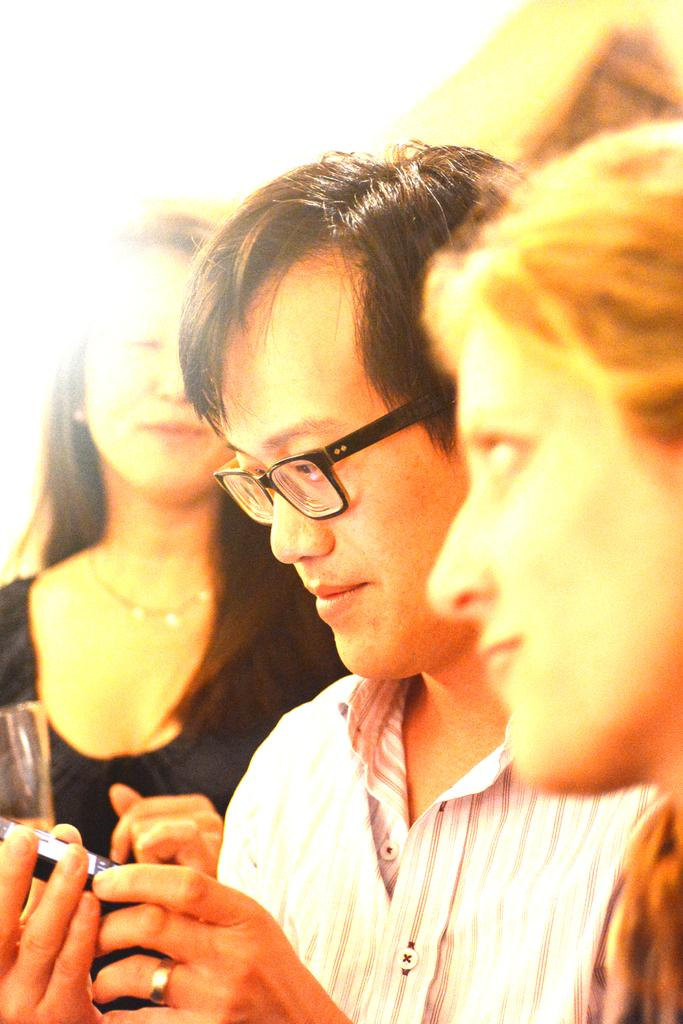Who are the people in the foreground of the image? There is a woman and a man in the foreground of the image. What is the man holding in the image? The man is holding a mobile in the image. Who is behind the man in the image? There is another woman behind the man in the image. What might the woman behind the man be holding? The woman behind the man appears to be holding a glass in the image. What is the price of the quarter that the man is holding in the image? There is no quarter present in the image, and therefore no price can be determined. 